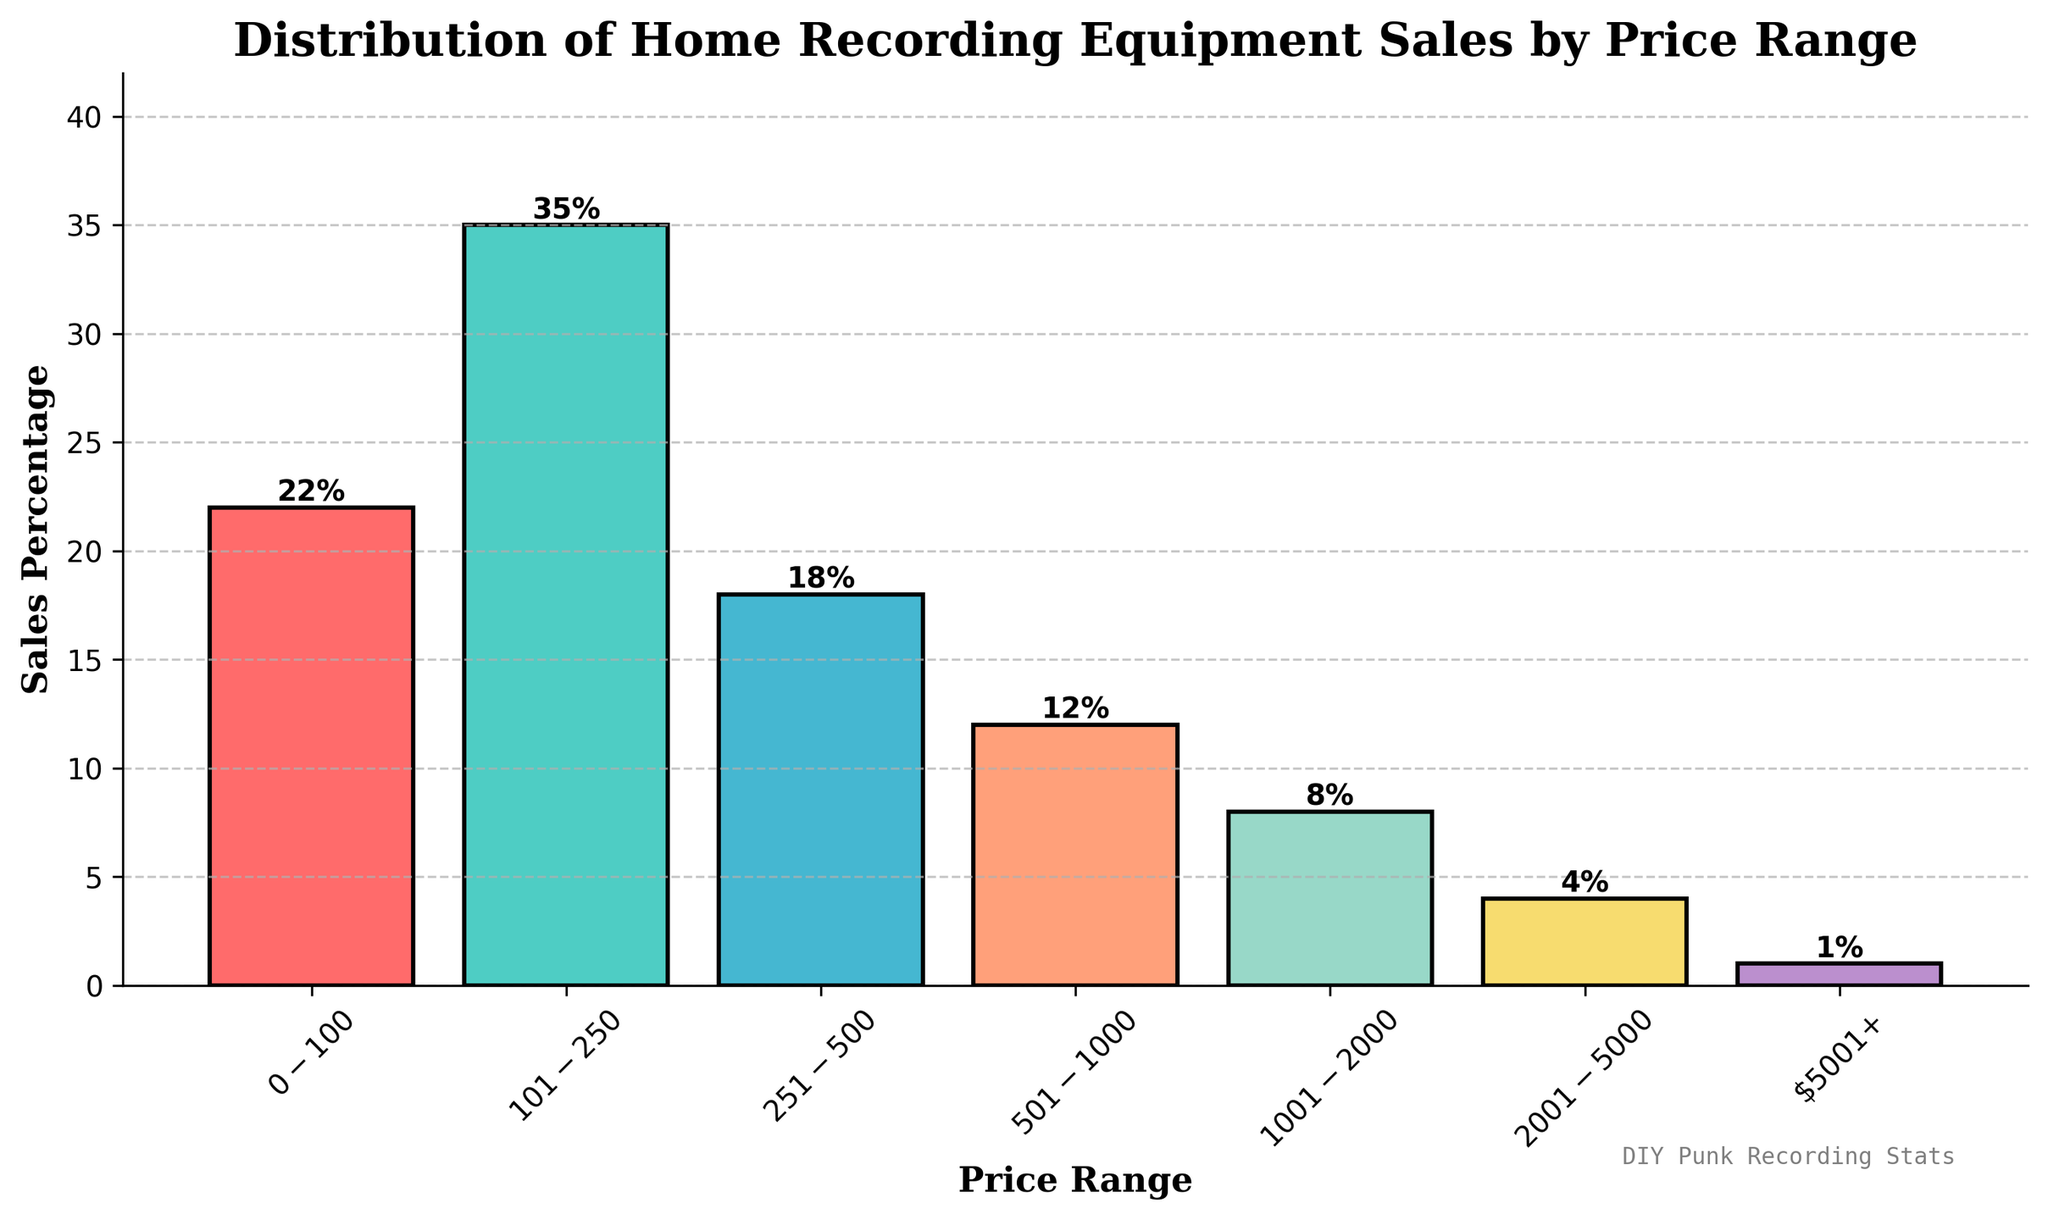Which price range has the highest sales percentage? To determine which price range has the highest sales percentage, look for the tallest bar in the bar chart. The $101-$250 price range bar is the tallest.
Answer: $101-$250 What is the total sales percentage for price ranges above $1000? Sum the sales percentages of the price ranges $1001-$2000, $2001-$5000, and $5001+. These values are 8, 4, and 1 respectively. 8 + 4 + 1 = 13.
Answer: 13 What is the difference in sales percentage between the $0-$100 and $501-$1000 price ranges? To find the difference, subtract the sales percentage of the $501-$1000 price range from the $0-$100 price range. 22 - 12 = 10.
Answer: 10 Is the sales percentage of the $251-$500 price range greater than the sum of the sales percentages for $2001-$5000 and $5001+? Compare the sales percentage of $251-$500 (18) with the sum of $2001-$5000 (4) and $5001+ (1). 18 is greater than 4 + 1 = 5.
Answer: Yes Which color represents the $101-$250 price range bar? Identify the color of the tallest bar corresponding to the $101-$250 price range. The color is green.
Answer: Green 